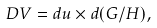<formula> <loc_0><loc_0><loc_500><loc_500>D V = d u \times d ( G / H ) ,</formula> 